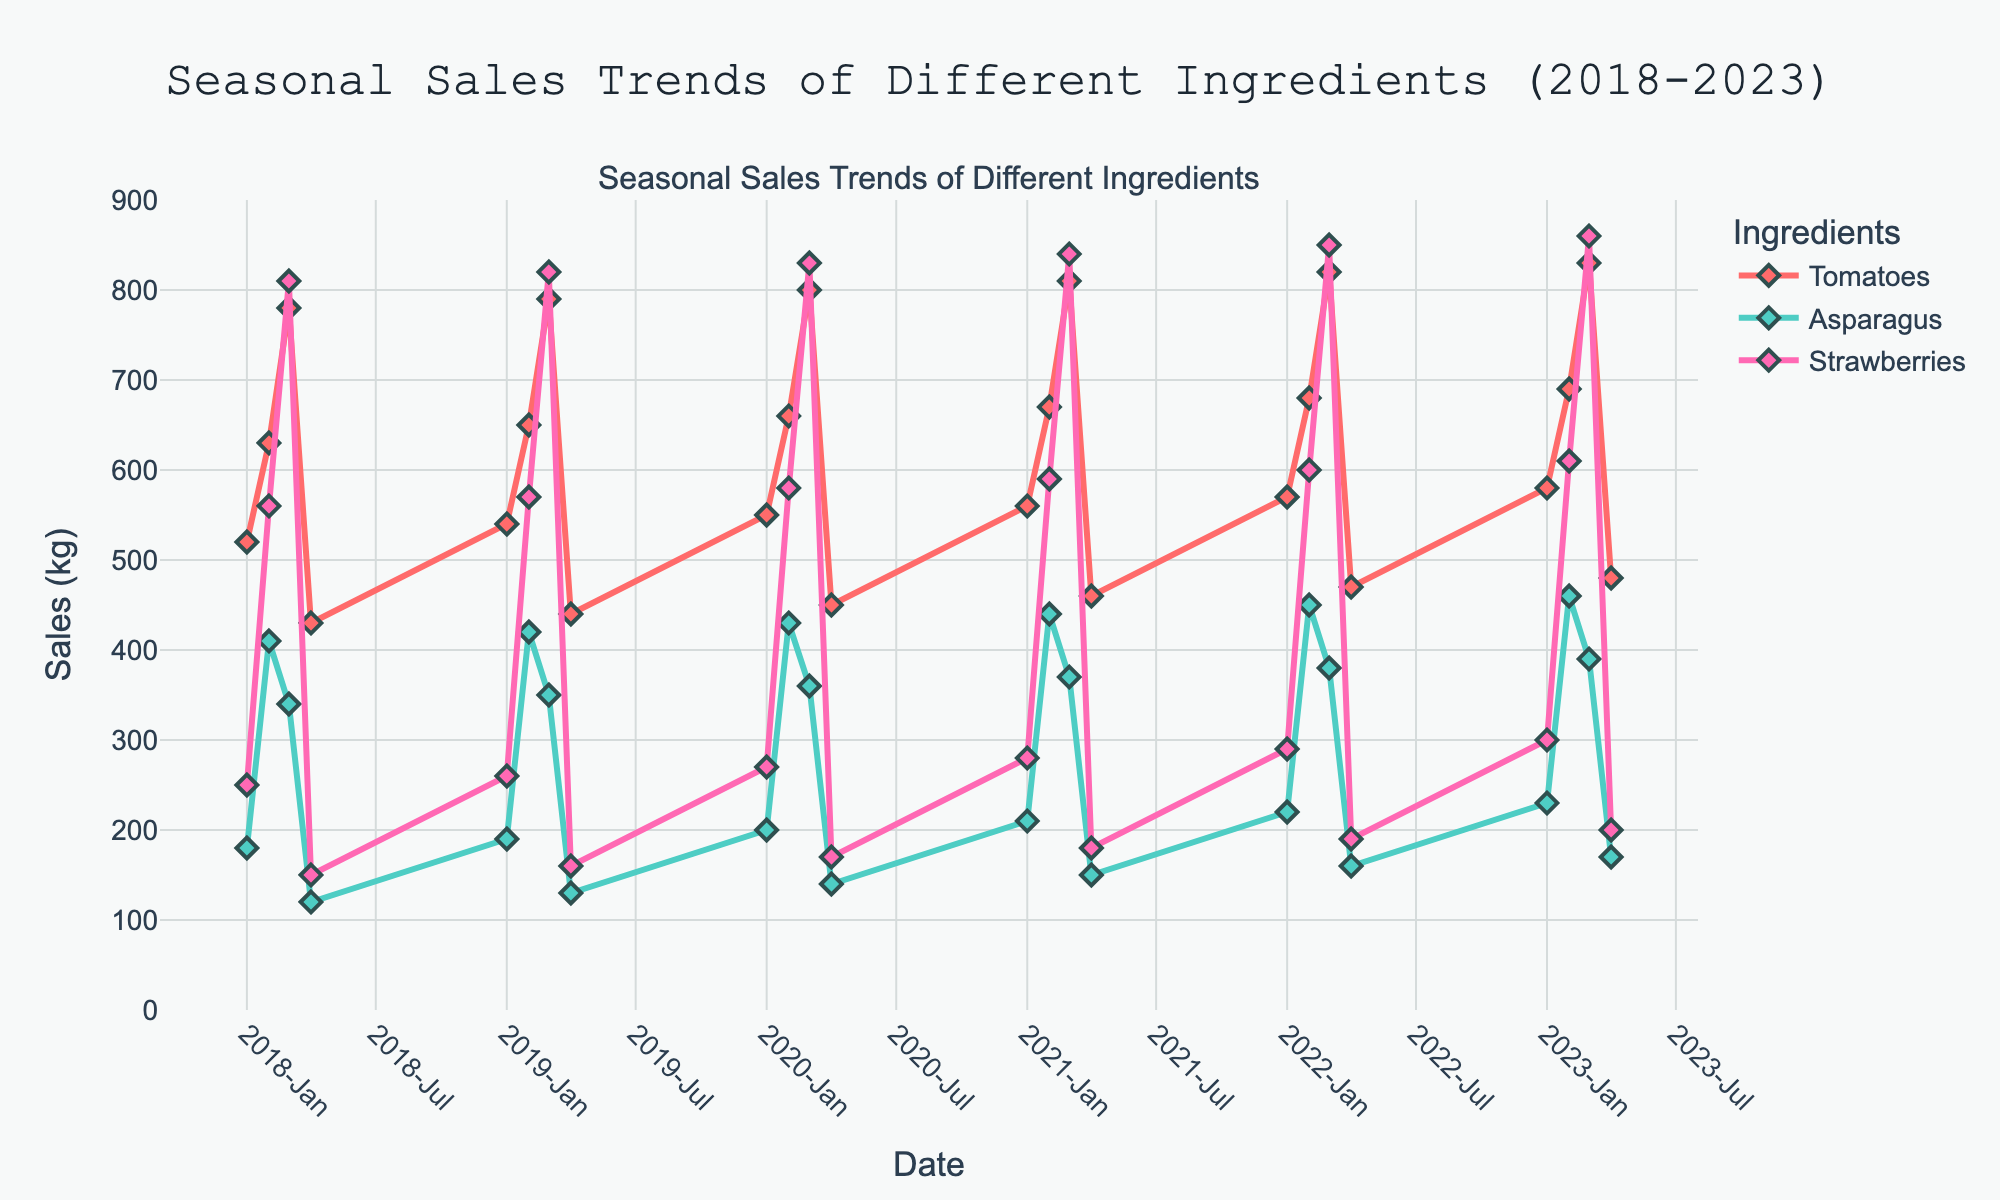What's the title of the plot? The title is located at the top of the plot. It reads "Seasonal Sales Trends of Different Ingredients (2018-2023)".
Answer: "Seasonal Sales Trends of Different Ingredients (2018-2023)" What are the ingredients listed in the legend? The legend shows the ingredients included in the time series plot. They are denoted with different colors and markers.
Answer: Tomatoes, Asparagus, Strawberries During which quarter and year did Strawberries reach their highest sales? The sales trend for Strawberries shows the highest peak in Q3 of 2023 on the x-axis, where the corresponding data point is the highest.
Answer: Q3 2023 What is the general trend of Tomato sales over the years? By looking at the trend line for Tomatoes, one can observe that sales generally increase each year, peaking in Q3 of each year, with a slight dip in Q4.
Answer: Increasing trend with Q3 peaks Compare the sales of Asparagus in Q2 and Q4 of 2021. Which period had higher sales? Locate the data points for Asparagus in Q2 and Q4 of 2021. The sales are higher in Q2 (440 kg) versus Q4 (150 kg).
Answer: Q2 2021 In which year did Tomatoes have their lowest Q4 sales? Find the lowest point for Q4 for Tomatoes. The lowest sales for Tomatoes in Q4 occurred in 2018 (430 kg).
Answer: 2018 What is the difference in sales for Strawberries between Q1 2018 and Q1 2023? Note the sales for Strawberries in Q1 2018 (250 kg) and Q1 2023 (300 kg). Subtract the values to find the difference.
Answer: 50 kg What pattern do you observe in the sales of Asparagus across different quarters each year? Observe the line for Asparagus and note that sales peak in Q2 and generally decrease through Q3 and Q4 each year.
Answer: Peak in Q2, decrease through the year How do the sales of Tomatoes in Q3 of each year compare to the other quarters? Review the trend line for Tomatoes and note that sales are consistently highest in Q3 compared to the other quarters each year.
Answer: Highest in Q3 What was the total sales of Strawberries in 2020? Sum the Strawberries sales across all quarters in 2020: 270 (Q1) + 580 (Q2) + 830 (Q3) + 170 (Q4) = 1850 kg.
Answer: 1850 kg 